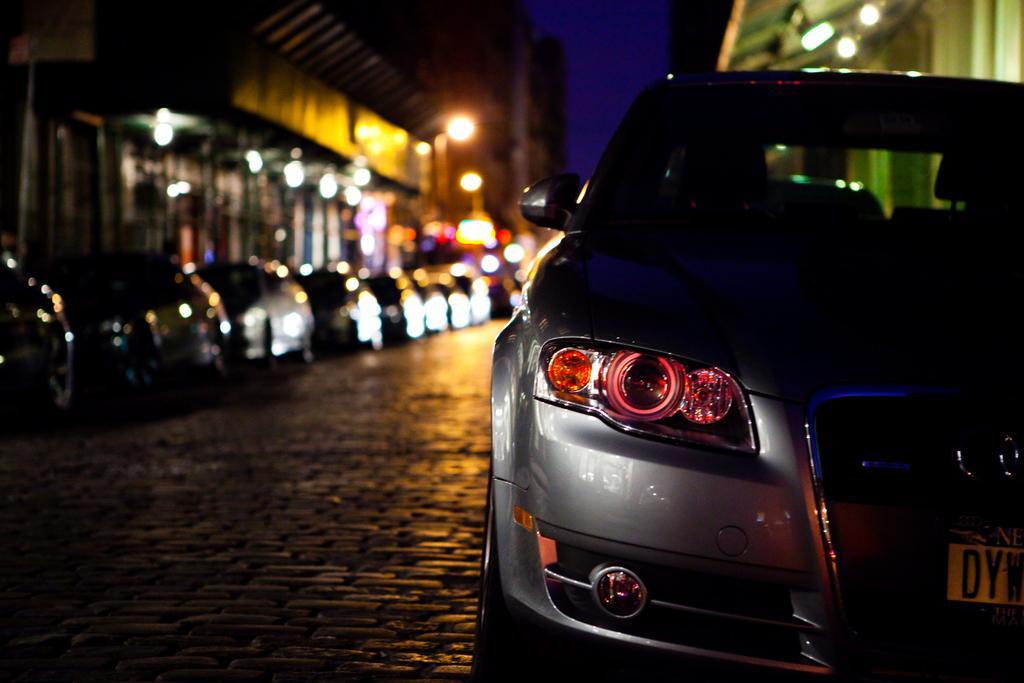Could you give a brief overview of what you see in this image? In this image we can see a group of cars parked on the road. In the background we can see buildings and sky. 